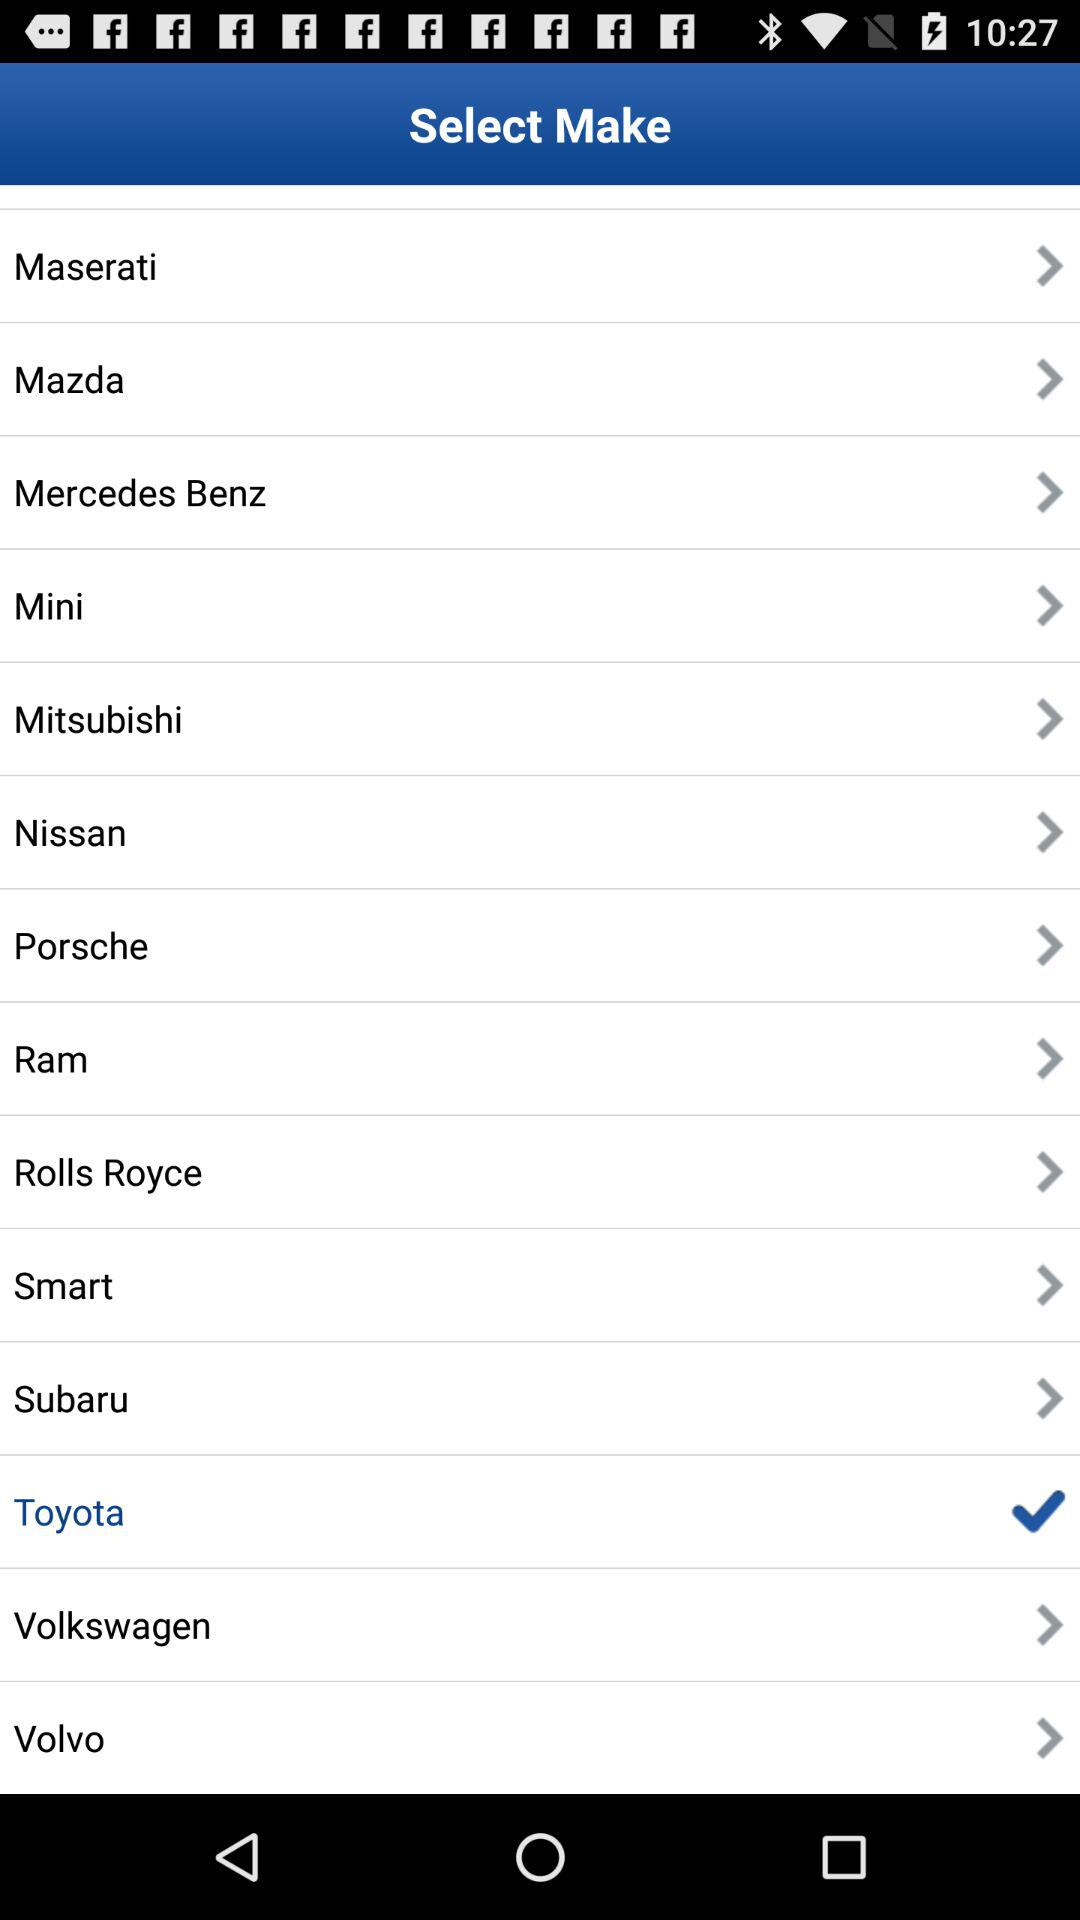What's the selected brand? The selected brand is "Toyota". 